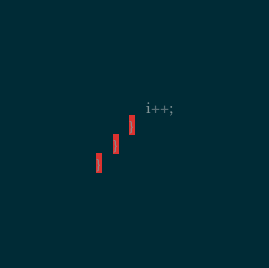<code> <loc_0><loc_0><loc_500><loc_500><_Haxe_>			i++;
		}
	}
}</code> 